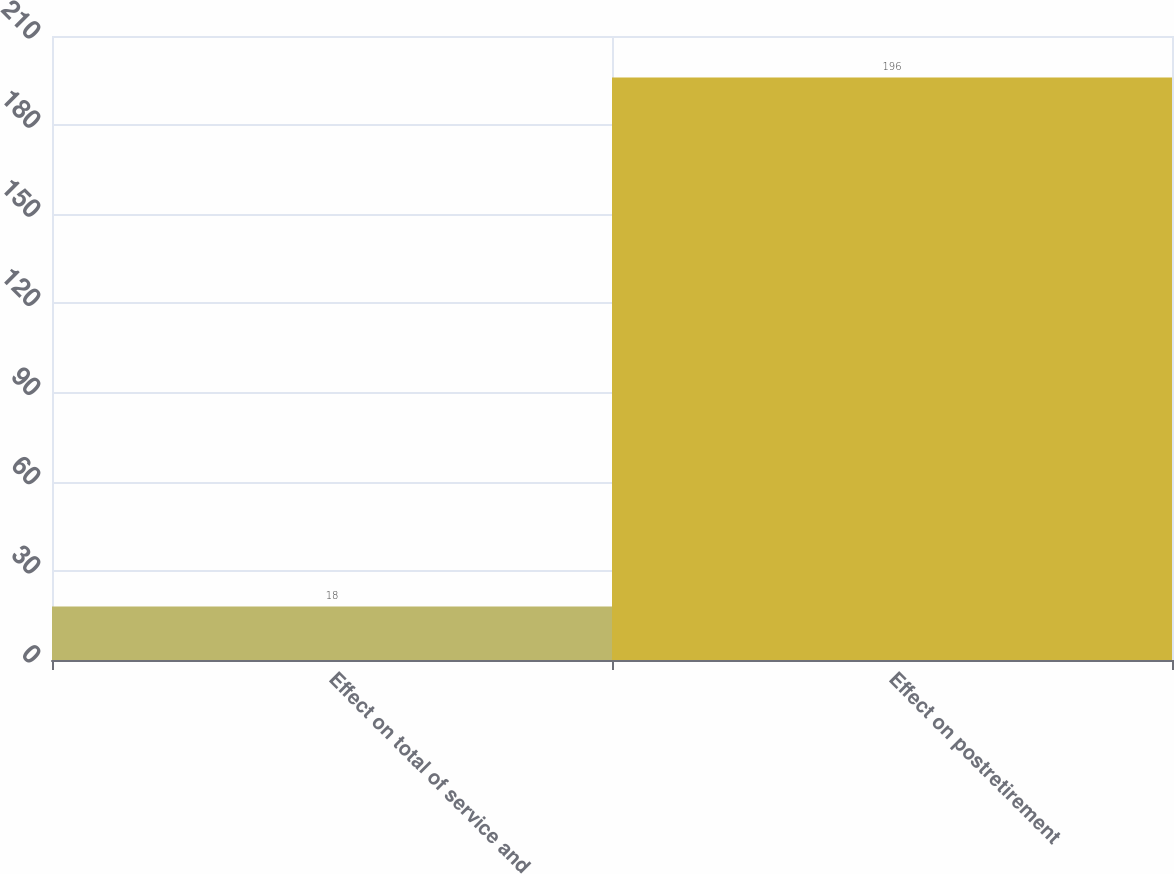Convert chart to OTSL. <chart><loc_0><loc_0><loc_500><loc_500><bar_chart><fcel>Effect on total of service and<fcel>Effect on postretirement<nl><fcel>18<fcel>196<nl></chart> 